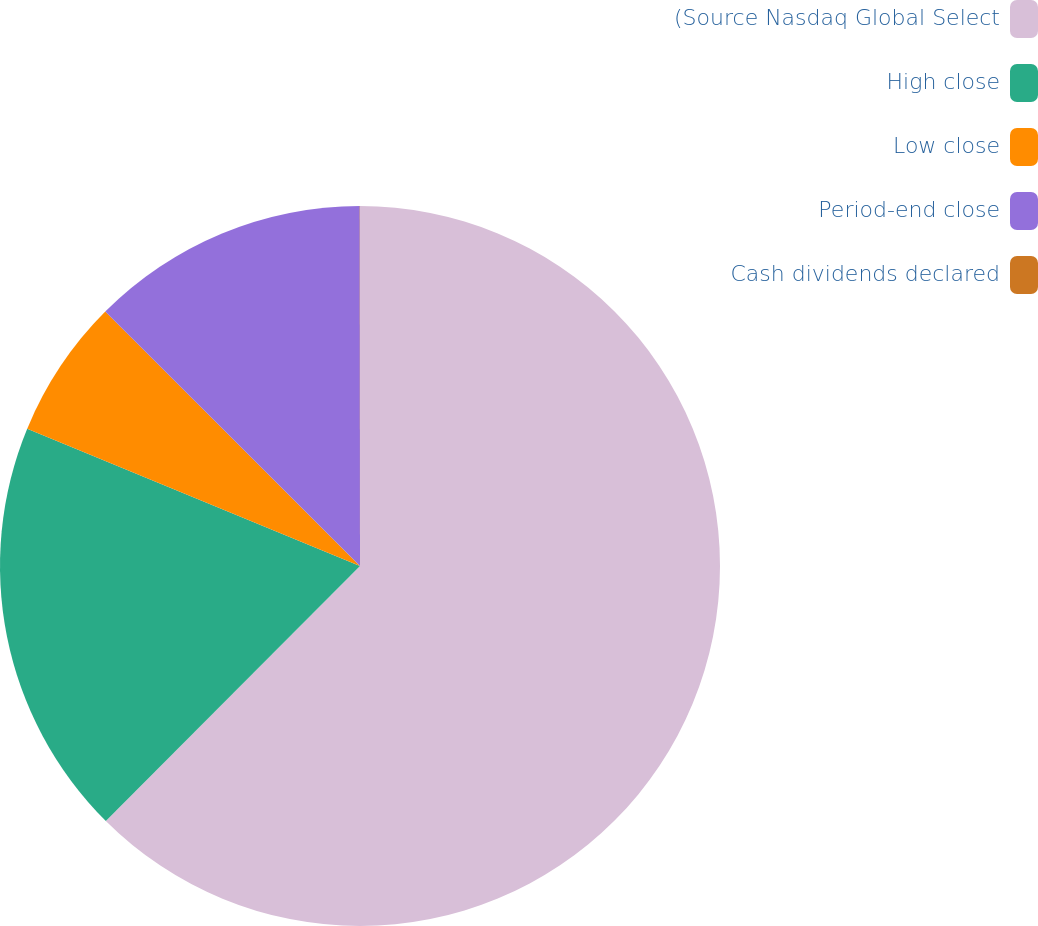Convert chart to OTSL. <chart><loc_0><loc_0><loc_500><loc_500><pie_chart><fcel>(Source Nasdaq Global Select<fcel>High close<fcel>Low close<fcel>Period-end close<fcel>Cash dividends declared<nl><fcel>62.47%<fcel>18.75%<fcel>6.26%<fcel>12.5%<fcel>0.01%<nl></chart> 